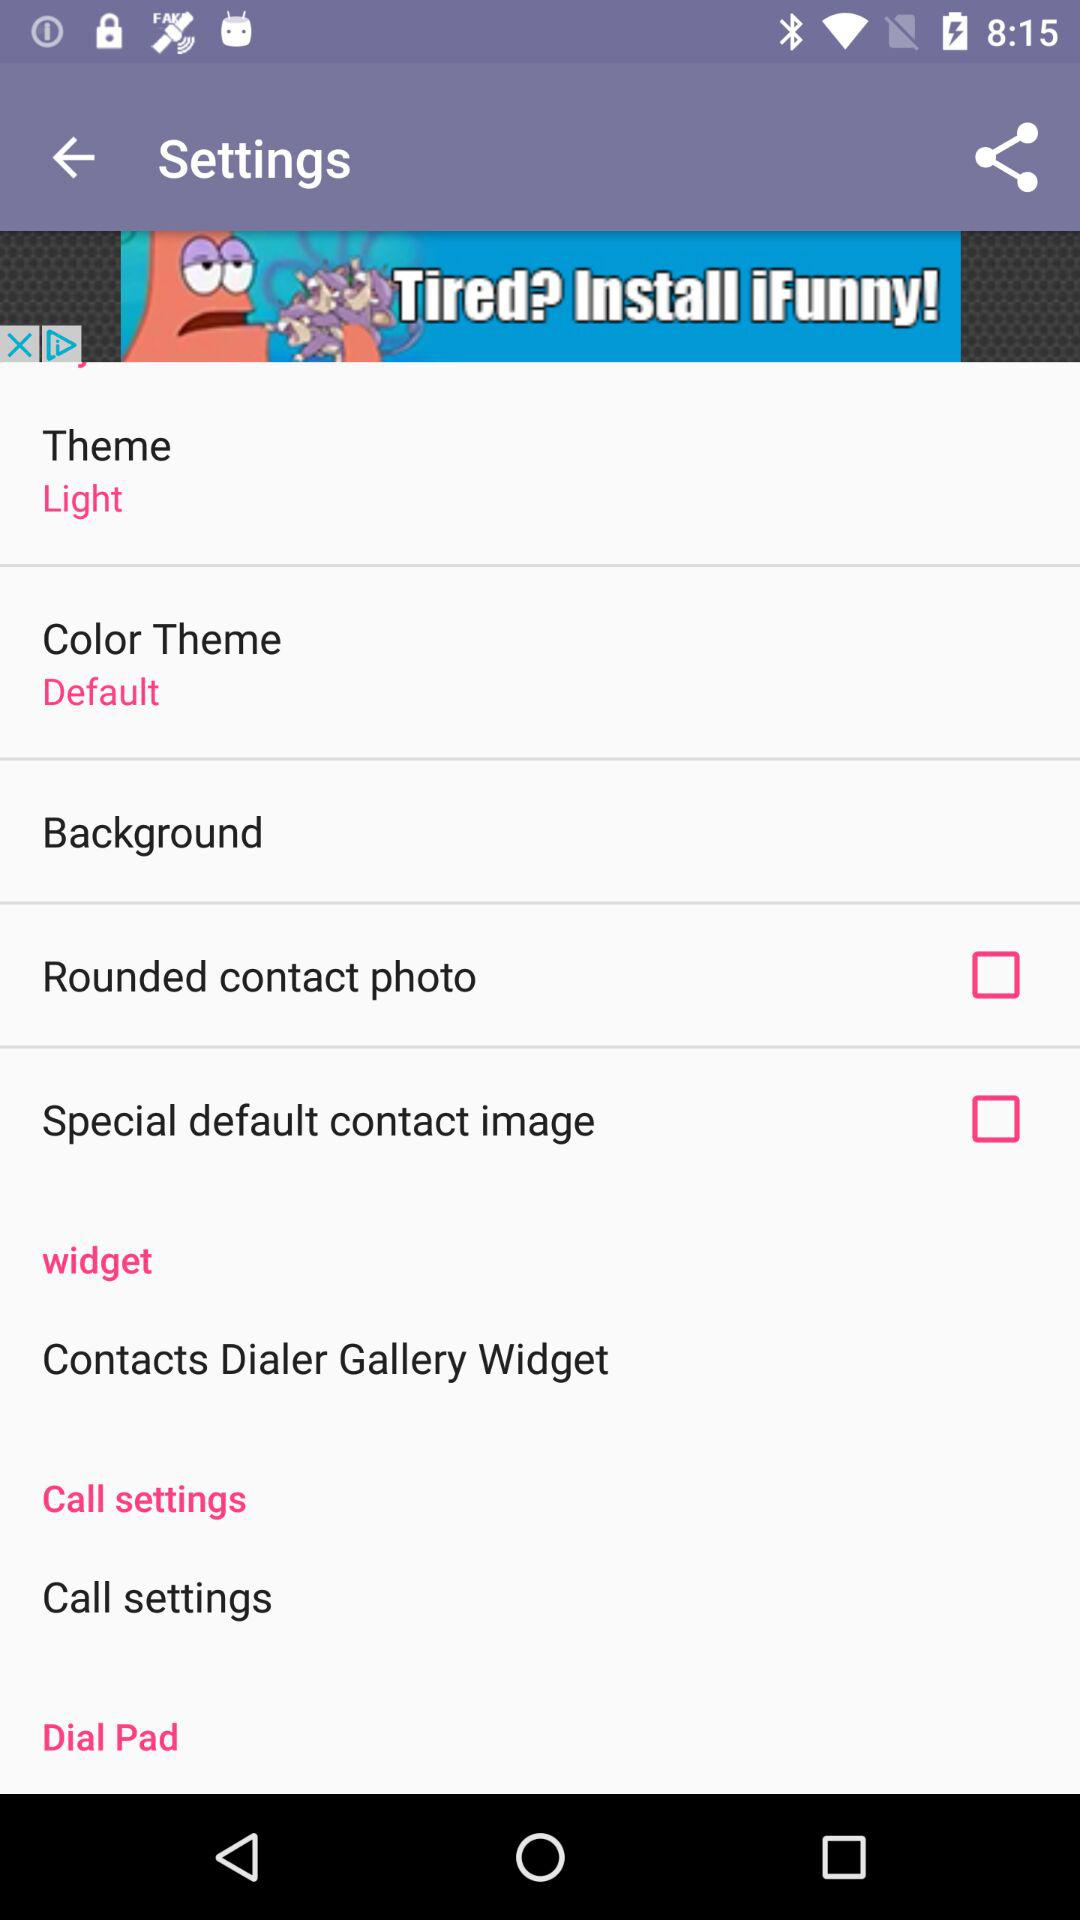What's the status of "Rounded contact photo"? The status is "off". 